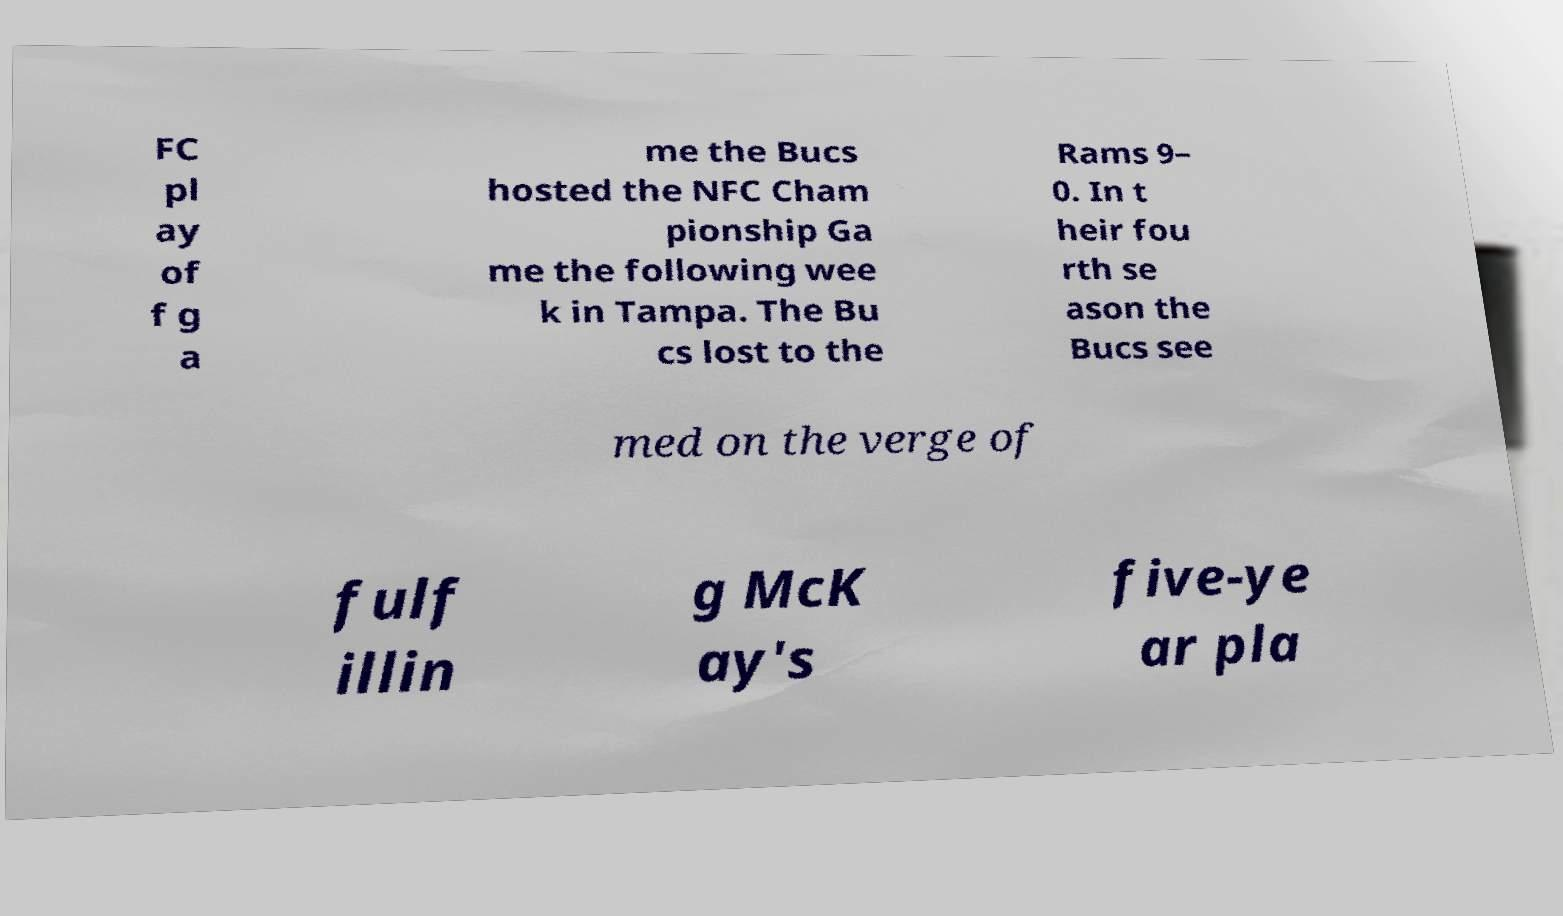Please read and relay the text visible in this image. What does it say? FC pl ay of f g a me the Bucs hosted the NFC Cham pionship Ga me the following wee k in Tampa. The Bu cs lost to the Rams 9– 0. In t heir fou rth se ason the Bucs see med on the verge of fulf illin g McK ay's five-ye ar pla 